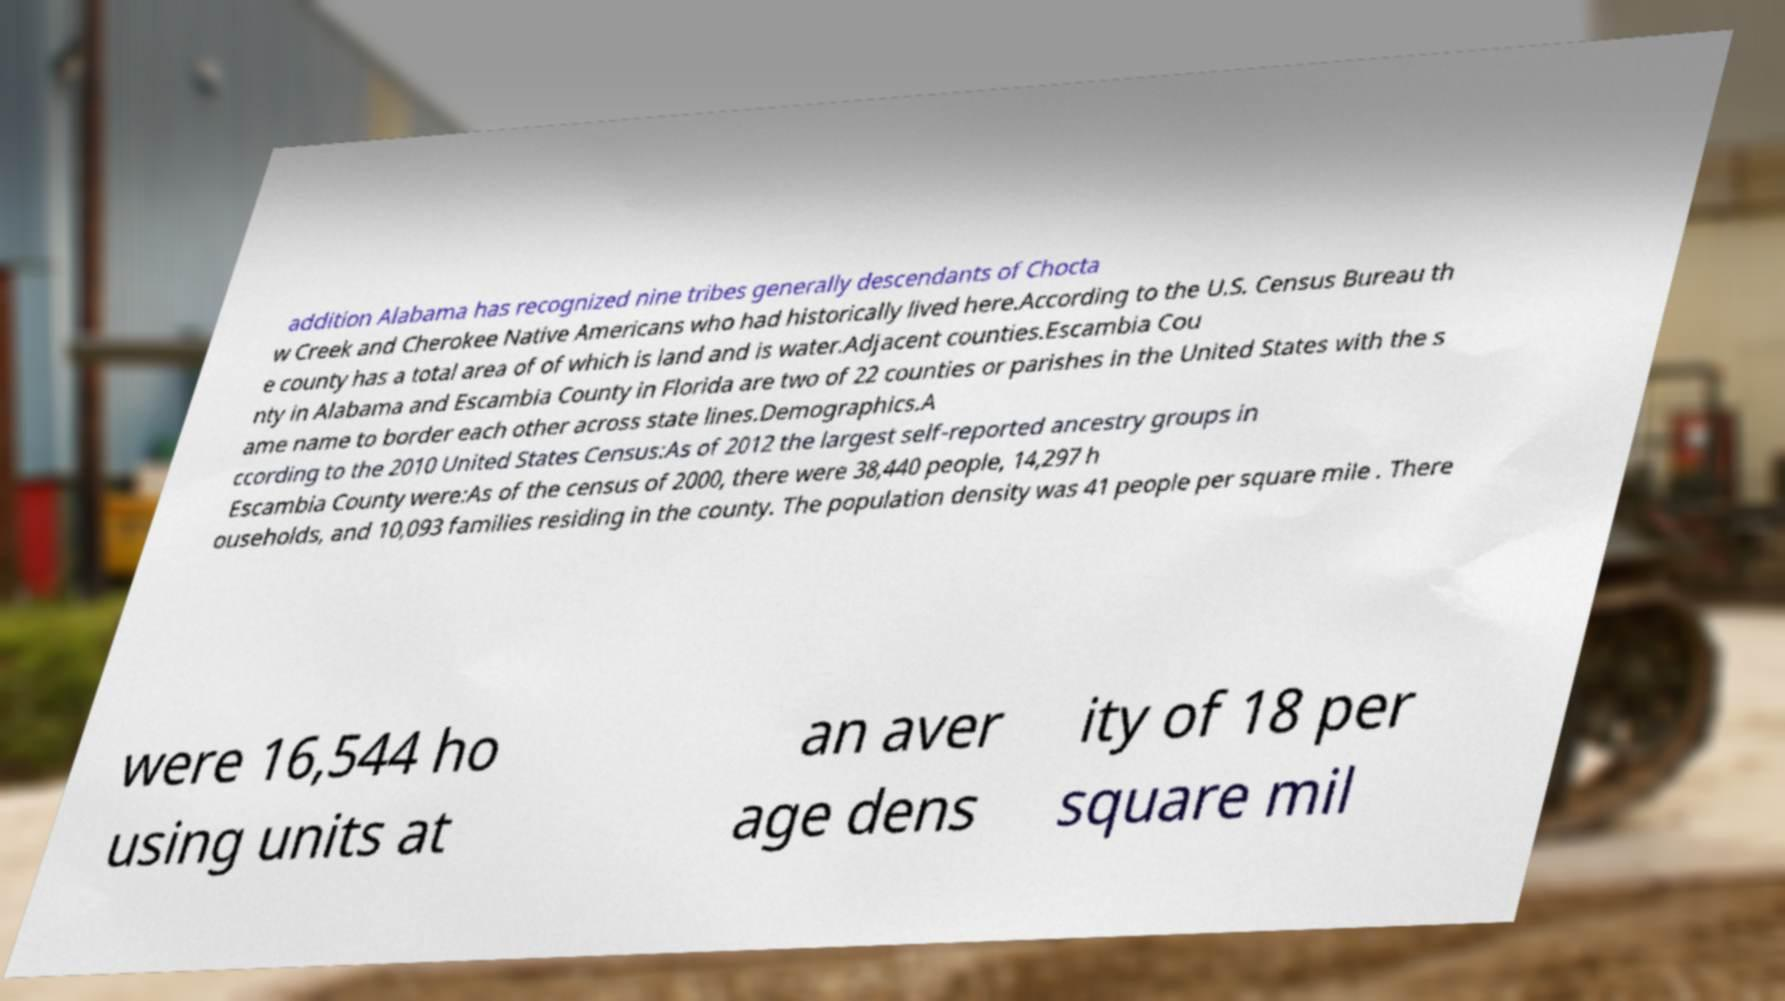Can you accurately transcribe the text from the provided image for me? addition Alabama has recognized nine tribes generally descendants of Chocta w Creek and Cherokee Native Americans who had historically lived here.According to the U.S. Census Bureau th e county has a total area of of which is land and is water.Adjacent counties.Escambia Cou nty in Alabama and Escambia County in Florida are two of 22 counties or parishes in the United States with the s ame name to border each other across state lines.Demographics.A ccording to the 2010 United States Census:As of 2012 the largest self-reported ancestry groups in Escambia County were:As of the census of 2000, there were 38,440 people, 14,297 h ouseholds, and 10,093 families residing in the county. The population density was 41 people per square mile . There were 16,544 ho using units at an aver age dens ity of 18 per square mil 